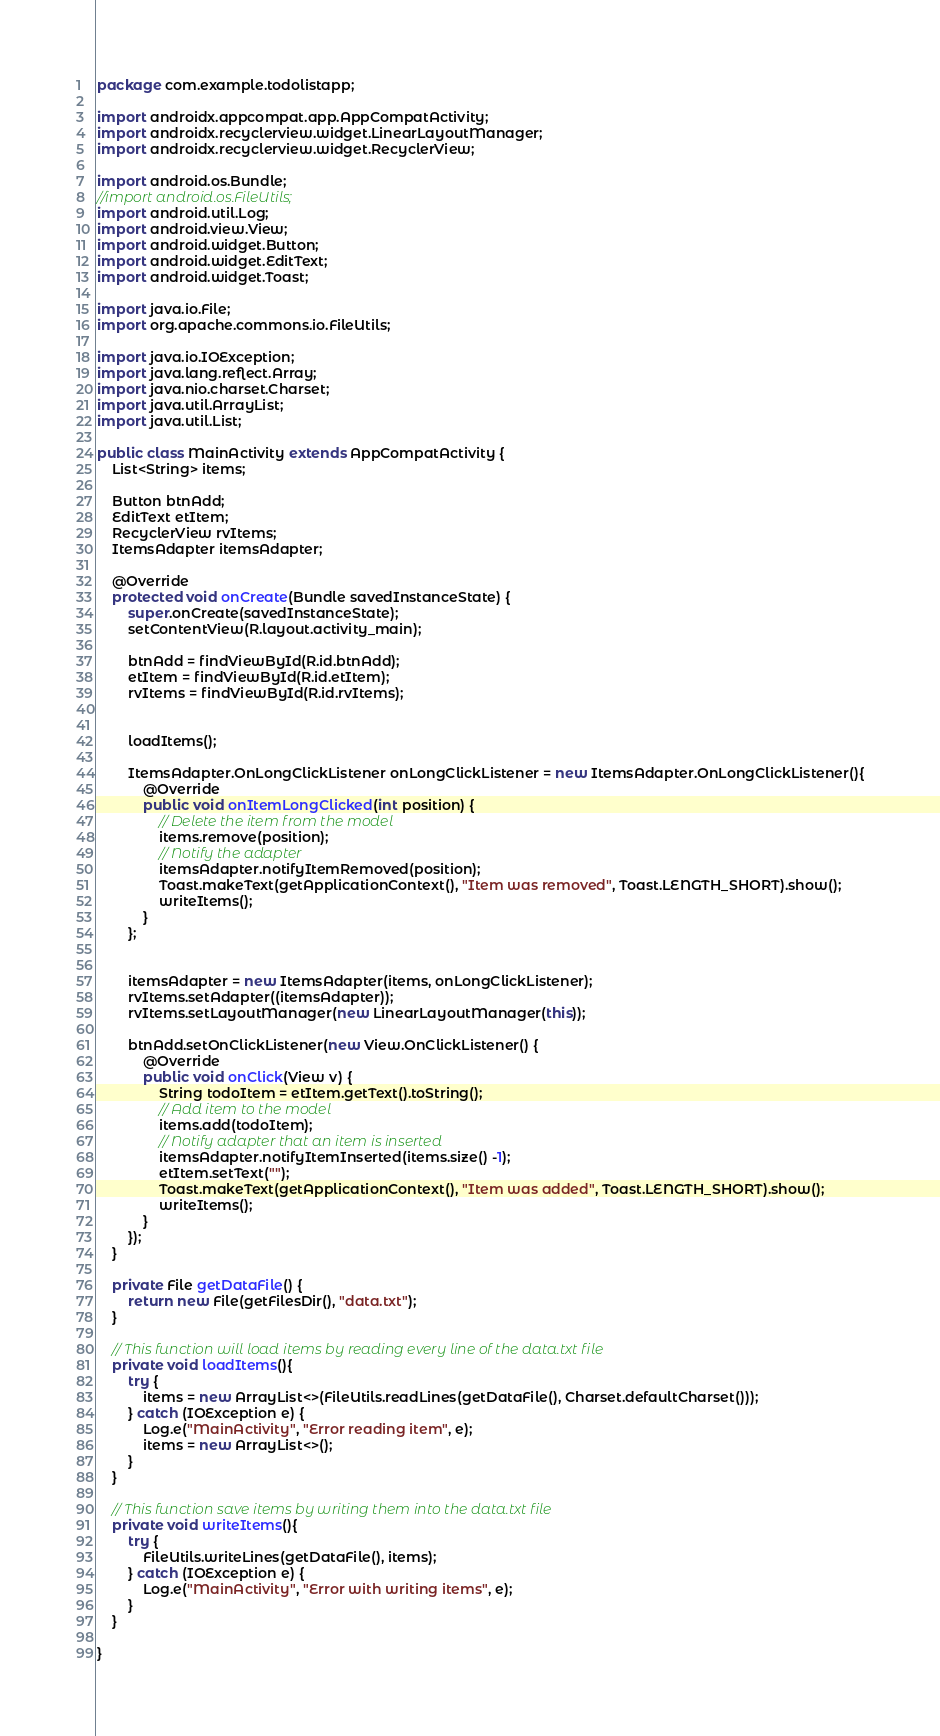<code> <loc_0><loc_0><loc_500><loc_500><_Java_>package com.example.todolistapp;

import androidx.appcompat.app.AppCompatActivity;
import androidx.recyclerview.widget.LinearLayoutManager;
import androidx.recyclerview.widget.RecyclerView;

import android.os.Bundle;
//import android.os.FileUtils;
import android.util.Log;
import android.view.View;
import android.widget.Button;
import android.widget.EditText;
import android.widget.Toast;

import java.io.File;
import org.apache.commons.io.FileUtils;

import java.io.IOException;
import java.lang.reflect.Array;
import java.nio.charset.Charset;
import java.util.ArrayList;
import java.util.List;

public class MainActivity extends AppCompatActivity {
    List<String> items;

    Button btnAdd;
    EditText etItem;
    RecyclerView rvItems;
    ItemsAdapter itemsAdapter;

    @Override
    protected void onCreate(Bundle savedInstanceState) {
        super.onCreate(savedInstanceState);
        setContentView(R.layout.activity_main);

        btnAdd = findViewById(R.id.btnAdd);
        etItem = findViewById(R.id.etItem);
        rvItems = findViewById(R.id.rvItems);


        loadItems();

        ItemsAdapter.OnLongClickListener onLongClickListener = new ItemsAdapter.OnLongClickListener(){
            @Override
            public void onItemLongClicked(int position) {
                // Delete the item from the model
                items.remove(position);
                // Notify the adapter
                itemsAdapter.notifyItemRemoved(position);
                Toast.makeText(getApplicationContext(), "Item was removed", Toast.LENGTH_SHORT).show();
                writeItems();
            }
        };


        itemsAdapter = new ItemsAdapter(items, onLongClickListener);
        rvItems.setAdapter((itemsAdapter));
        rvItems.setLayoutManager(new LinearLayoutManager(this));

        btnAdd.setOnClickListener(new View.OnClickListener() {
            @Override
            public void onClick(View v) {
                String todoItem = etItem.getText().toString();
                // Add item to the model
                items.add(todoItem);
                // Notify adapter that an item is inserted
                itemsAdapter.notifyItemInserted(items.size() -1);
                etItem.setText("");
                Toast.makeText(getApplicationContext(), "Item was added", Toast.LENGTH_SHORT).show();
                writeItems();
            }
        });
    }

    private File getDataFile() {
        return new File(getFilesDir(), "data.txt");
    }

    // This function will load items by reading every line of the data.txt file
    private void loadItems(){
        try {
            items = new ArrayList<>(FileUtils.readLines(getDataFile(), Charset.defaultCharset()));
        } catch (IOException e) {
            Log.e("MainActivity", "Error reading item", e);
            items = new ArrayList<>();
        }
    }

    // This function save items by writing them into the data.txt file
    private void writeItems(){
        try {
            FileUtils.writeLines(getDataFile(), items);
        } catch (IOException e) {
            Log.e("MainActivity", "Error with writing items", e);
        }
    }

}
</code> 